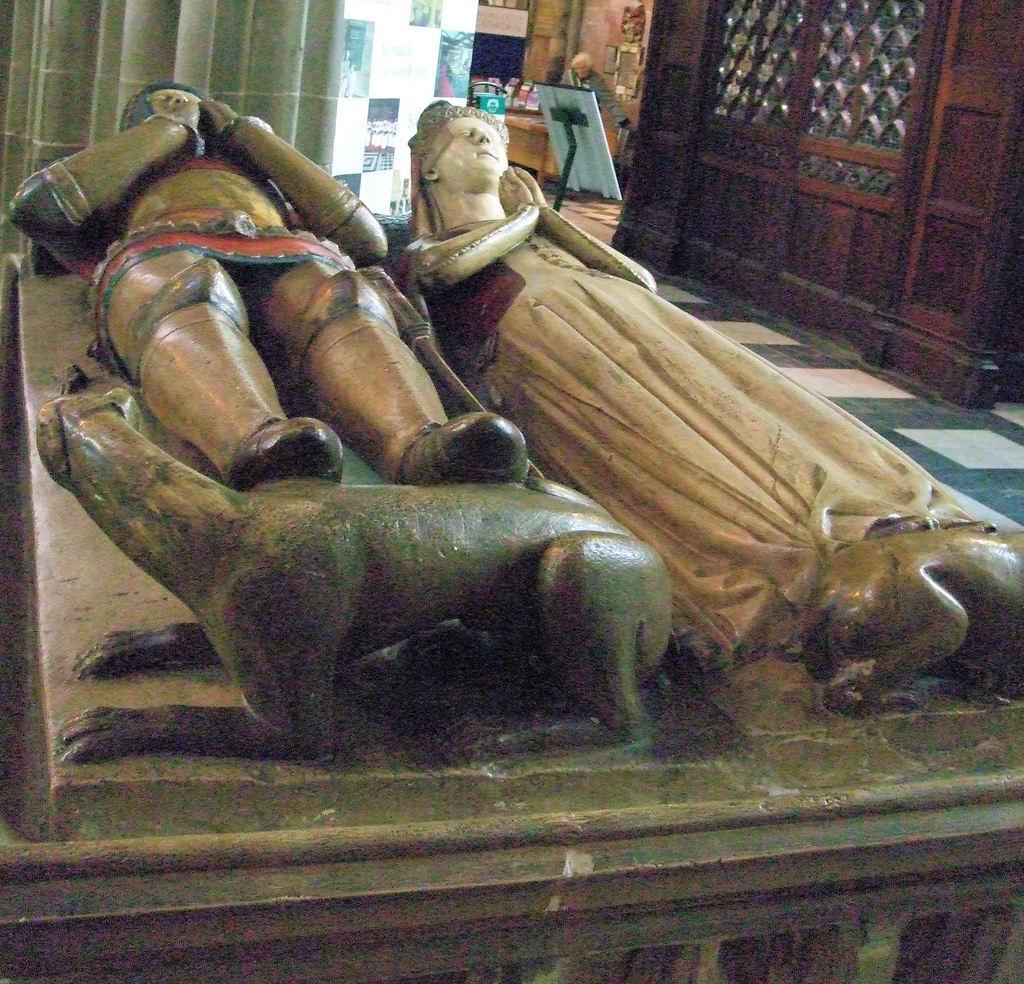How would you summarize this image in a sentence or two? In this image there are sculptures on a wall. In the top left there is a curtain. In the top right there is a wooden wall. Beside it there are a few objects. 